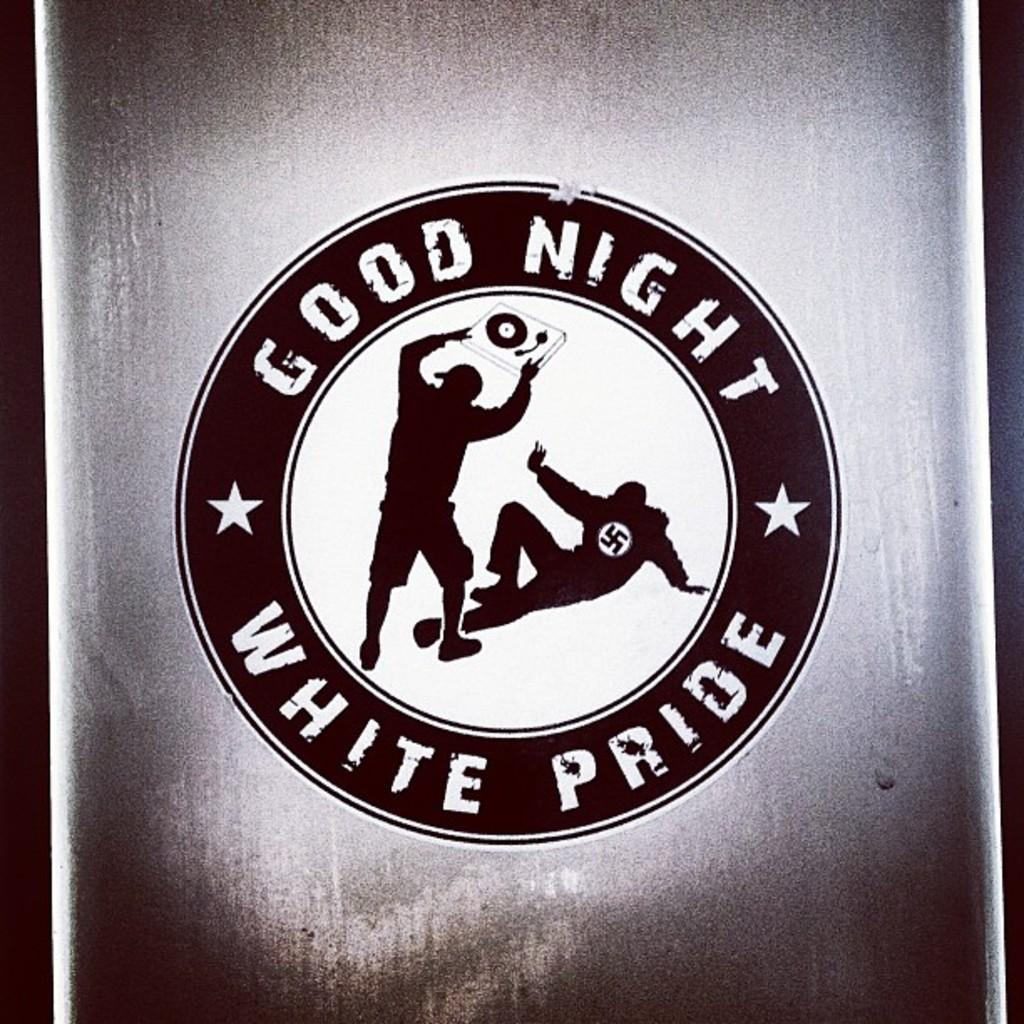<image>
Offer a succinct explanation of the picture presented. a logo that says 'good night white pride' on it 